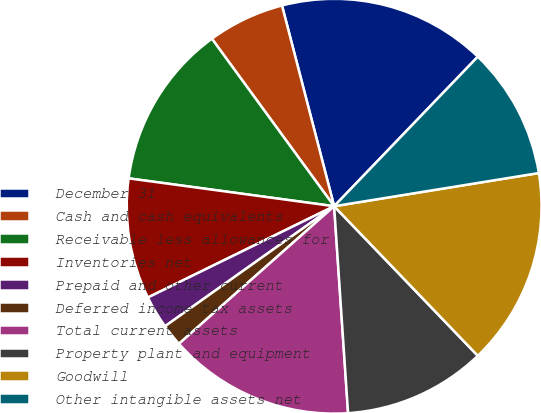<chart> <loc_0><loc_0><loc_500><loc_500><pie_chart><fcel>December 31<fcel>Cash and cash equivalents<fcel>Receivable less allowances for<fcel>Inventories net<fcel>Prepaid and other current<fcel>Deferred income tax assets<fcel>Total current assets<fcel>Property plant and equipment<fcel>Goodwill<fcel>Other intangible assets net<nl><fcel>16.23%<fcel>5.99%<fcel>12.82%<fcel>9.4%<fcel>2.57%<fcel>1.72%<fcel>14.53%<fcel>11.11%<fcel>15.38%<fcel>10.26%<nl></chart> 